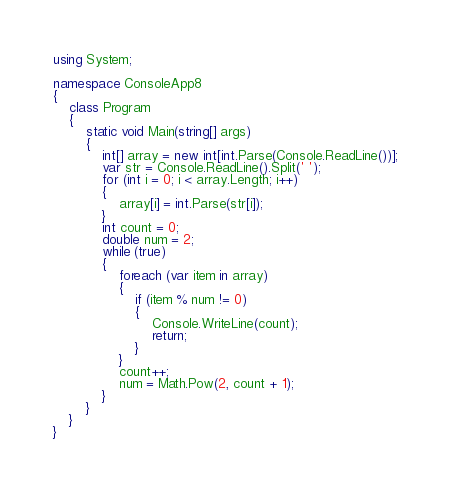<code> <loc_0><loc_0><loc_500><loc_500><_C#_>using System;

namespace ConsoleApp8
{
	class Program
	{
		static void Main(string[] args)
		{
			int[] array = new int[int.Parse(Console.ReadLine())];
			var str = Console.ReadLine().Split(' ');
			for (int i = 0; i < array.Length; i++)
			{
				array[i] = int.Parse(str[i]);
			}
			int count = 0;
			double num = 2;
			while (true)
			{
				foreach (var item in array)
				{
					if (item % num != 0)
					{
						Console.WriteLine(count);
						return;
					}
				}
				count++;
				num = Math.Pow(2, count + 1);
			}
		}
	}
}
</code> 